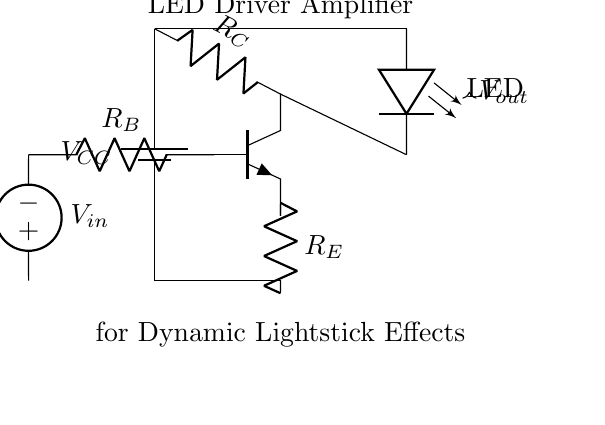What is the power supply voltage in this circuit? The power supply voltage is labeled as V_CC in the circuit. It is typically indicated at the top of the circuit diagram where the battery symbol is located.
Answer: V_CC What type of transistor is used in this circuit? The transistor is labeled as npn in the circuit diagram, which indicates it is an NPN transistor. This can be identified by the labeling near the component and the arrangement of its connections.
Answer: NPN What is the function of the resistor labeled R_B? Resistor R_B acts as a base resistor for the NPN transistor. It helps limit the current flowing into the base of the transistor, thus controlling the transistor's operation. This is a common function of the base resistor in transistor circuits.
Answer: Base resistor What is the output voltage represented in this circuit? The output voltage is indicated by the label V_out with an arrow pointing away from the circuit. This signifies it is the voltage measured across the load, which is the LED in this case.
Answer: V_out How many resistors are present in the circuit? There are three resistors present in the circuit labeled R_B (base resistor), R_C (collector resistor), and R_E (emitter resistor). These can be counted based on their labels shown in the diagram.
Answer: Three What is the purpose of the LED in this circuit? The LED in the circuit functions as the light source that creates dynamic lightstick effects. It is the load connected to the output of the amplifier, indicating the use of the circuit for lighting applications.
Answer: Light source 